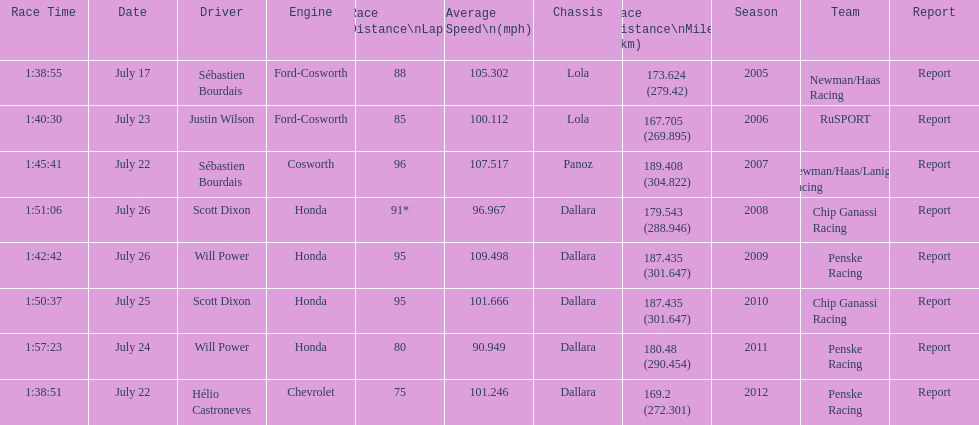Could you parse the entire table? {'header': ['Race Time', 'Date', 'Driver', 'Engine', 'Race Distance\\nLaps', 'Average Speed\\n(mph)', 'Chassis', 'Race Distance\\nMiles (km)', 'Season', 'Team', 'Report'], 'rows': [['1:38:55', 'July 17', 'Sébastien Bourdais', 'Ford-Cosworth', '88', '105.302', 'Lola', '173.624 (279.42)', '2005', 'Newman/Haas Racing', 'Report'], ['1:40:30', 'July 23', 'Justin Wilson', 'Ford-Cosworth', '85', '100.112', 'Lola', '167.705 (269.895)', '2006', 'RuSPORT', 'Report'], ['1:45:41', 'July 22', 'Sébastien Bourdais', 'Cosworth', '96', '107.517', 'Panoz', '189.408 (304.822)', '2007', 'Newman/Haas/Lanigan Racing', 'Report'], ['1:51:06', 'July 26', 'Scott Dixon', 'Honda', '91*', '96.967', 'Dallara', '179.543 (288.946)', '2008', 'Chip Ganassi Racing', 'Report'], ['1:42:42', 'July 26', 'Will Power', 'Honda', '95', '109.498', 'Dallara', '187.435 (301.647)', '2009', 'Penske Racing', 'Report'], ['1:50:37', 'July 25', 'Scott Dixon', 'Honda', '95', '101.666', 'Dallara', '187.435 (301.647)', '2010', 'Chip Ganassi Racing', 'Report'], ['1:57:23', 'July 24', 'Will Power', 'Honda', '80', '90.949', 'Dallara', '180.48 (290.454)', '2011', 'Penske Racing', 'Report'], ['1:38:51', 'July 22', 'Hélio Castroneves', 'Chevrolet', '75', '101.246', 'Dallara', '169.2 (272.301)', '2012', 'Penske Racing', 'Report']]} What is the total number dallara chassis listed in the table? 5. 